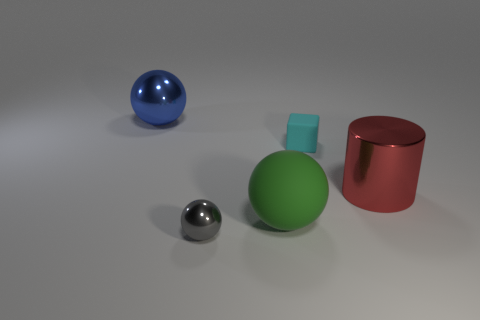Is there a tiny cyan rubber block?
Provide a short and direct response. Yes. Does the object on the left side of the gray shiny object have the same shape as the large metal thing that is in front of the large blue metal sphere?
Provide a succinct answer. No. Are there any cyan objects that have the same material as the tiny gray ball?
Offer a terse response. No. Does the blue thing that is behind the large green sphere have the same material as the small gray sphere?
Provide a succinct answer. Yes. Is the number of small spheres in front of the tiny gray metal thing greater than the number of red metallic cylinders that are behind the cyan object?
Offer a terse response. No. The other rubber ball that is the same size as the blue ball is what color?
Offer a terse response. Green. Is there a metal ball of the same color as the cube?
Your response must be concise. No. There is a big ball behind the cyan thing; is its color the same as the big object that is on the right side of the block?
Your answer should be very brief. No. There is a sphere that is behind the big cylinder; what material is it?
Offer a terse response. Metal. What is the color of the small thing that is made of the same material as the large blue thing?
Provide a succinct answer. Gray. 